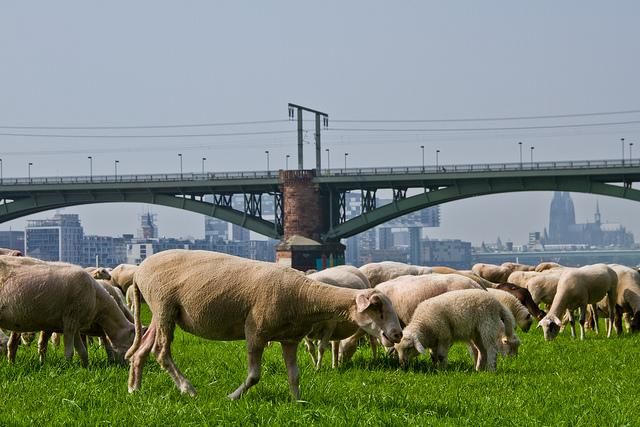What are the animals near? Please explain your reasoning. bridge. The sheep are by a bridge. 